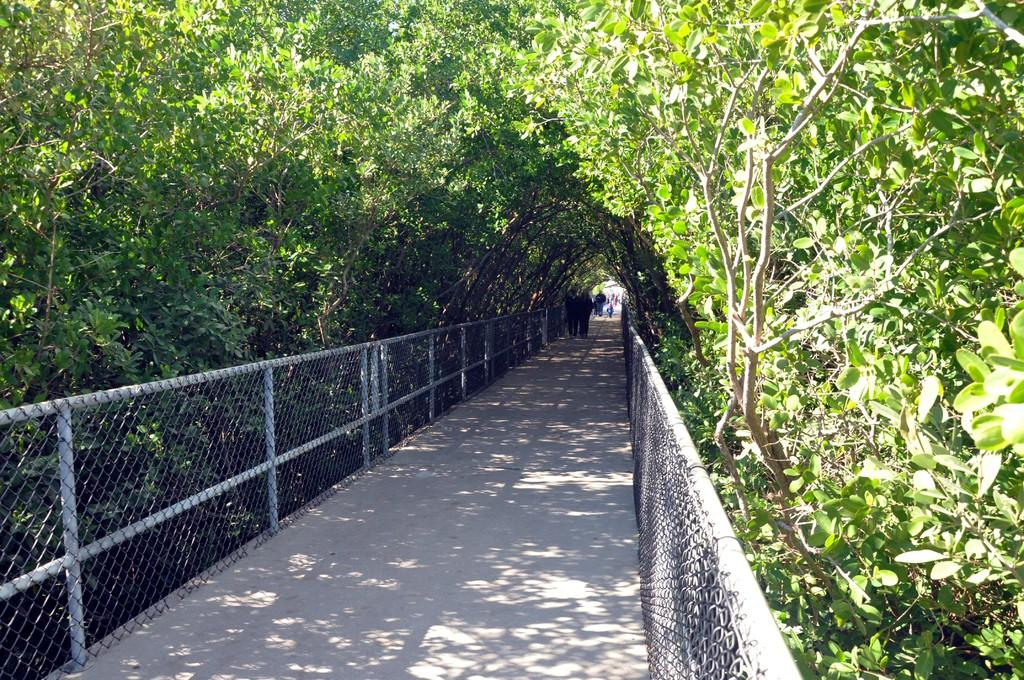What is the main feature in the center of the image? There is a walkway in the center of the image. What surrounds the walkway? There are fences on either side of the walkway. Are there any people visible in the image? Yes, there are people present at the back of the image. What type of vegetation can be seen in the image? There are plants visible in the image. What type of corn is being harvested in the image? There is no corn present in the image; it features a walkway, fences, people, and plants. 